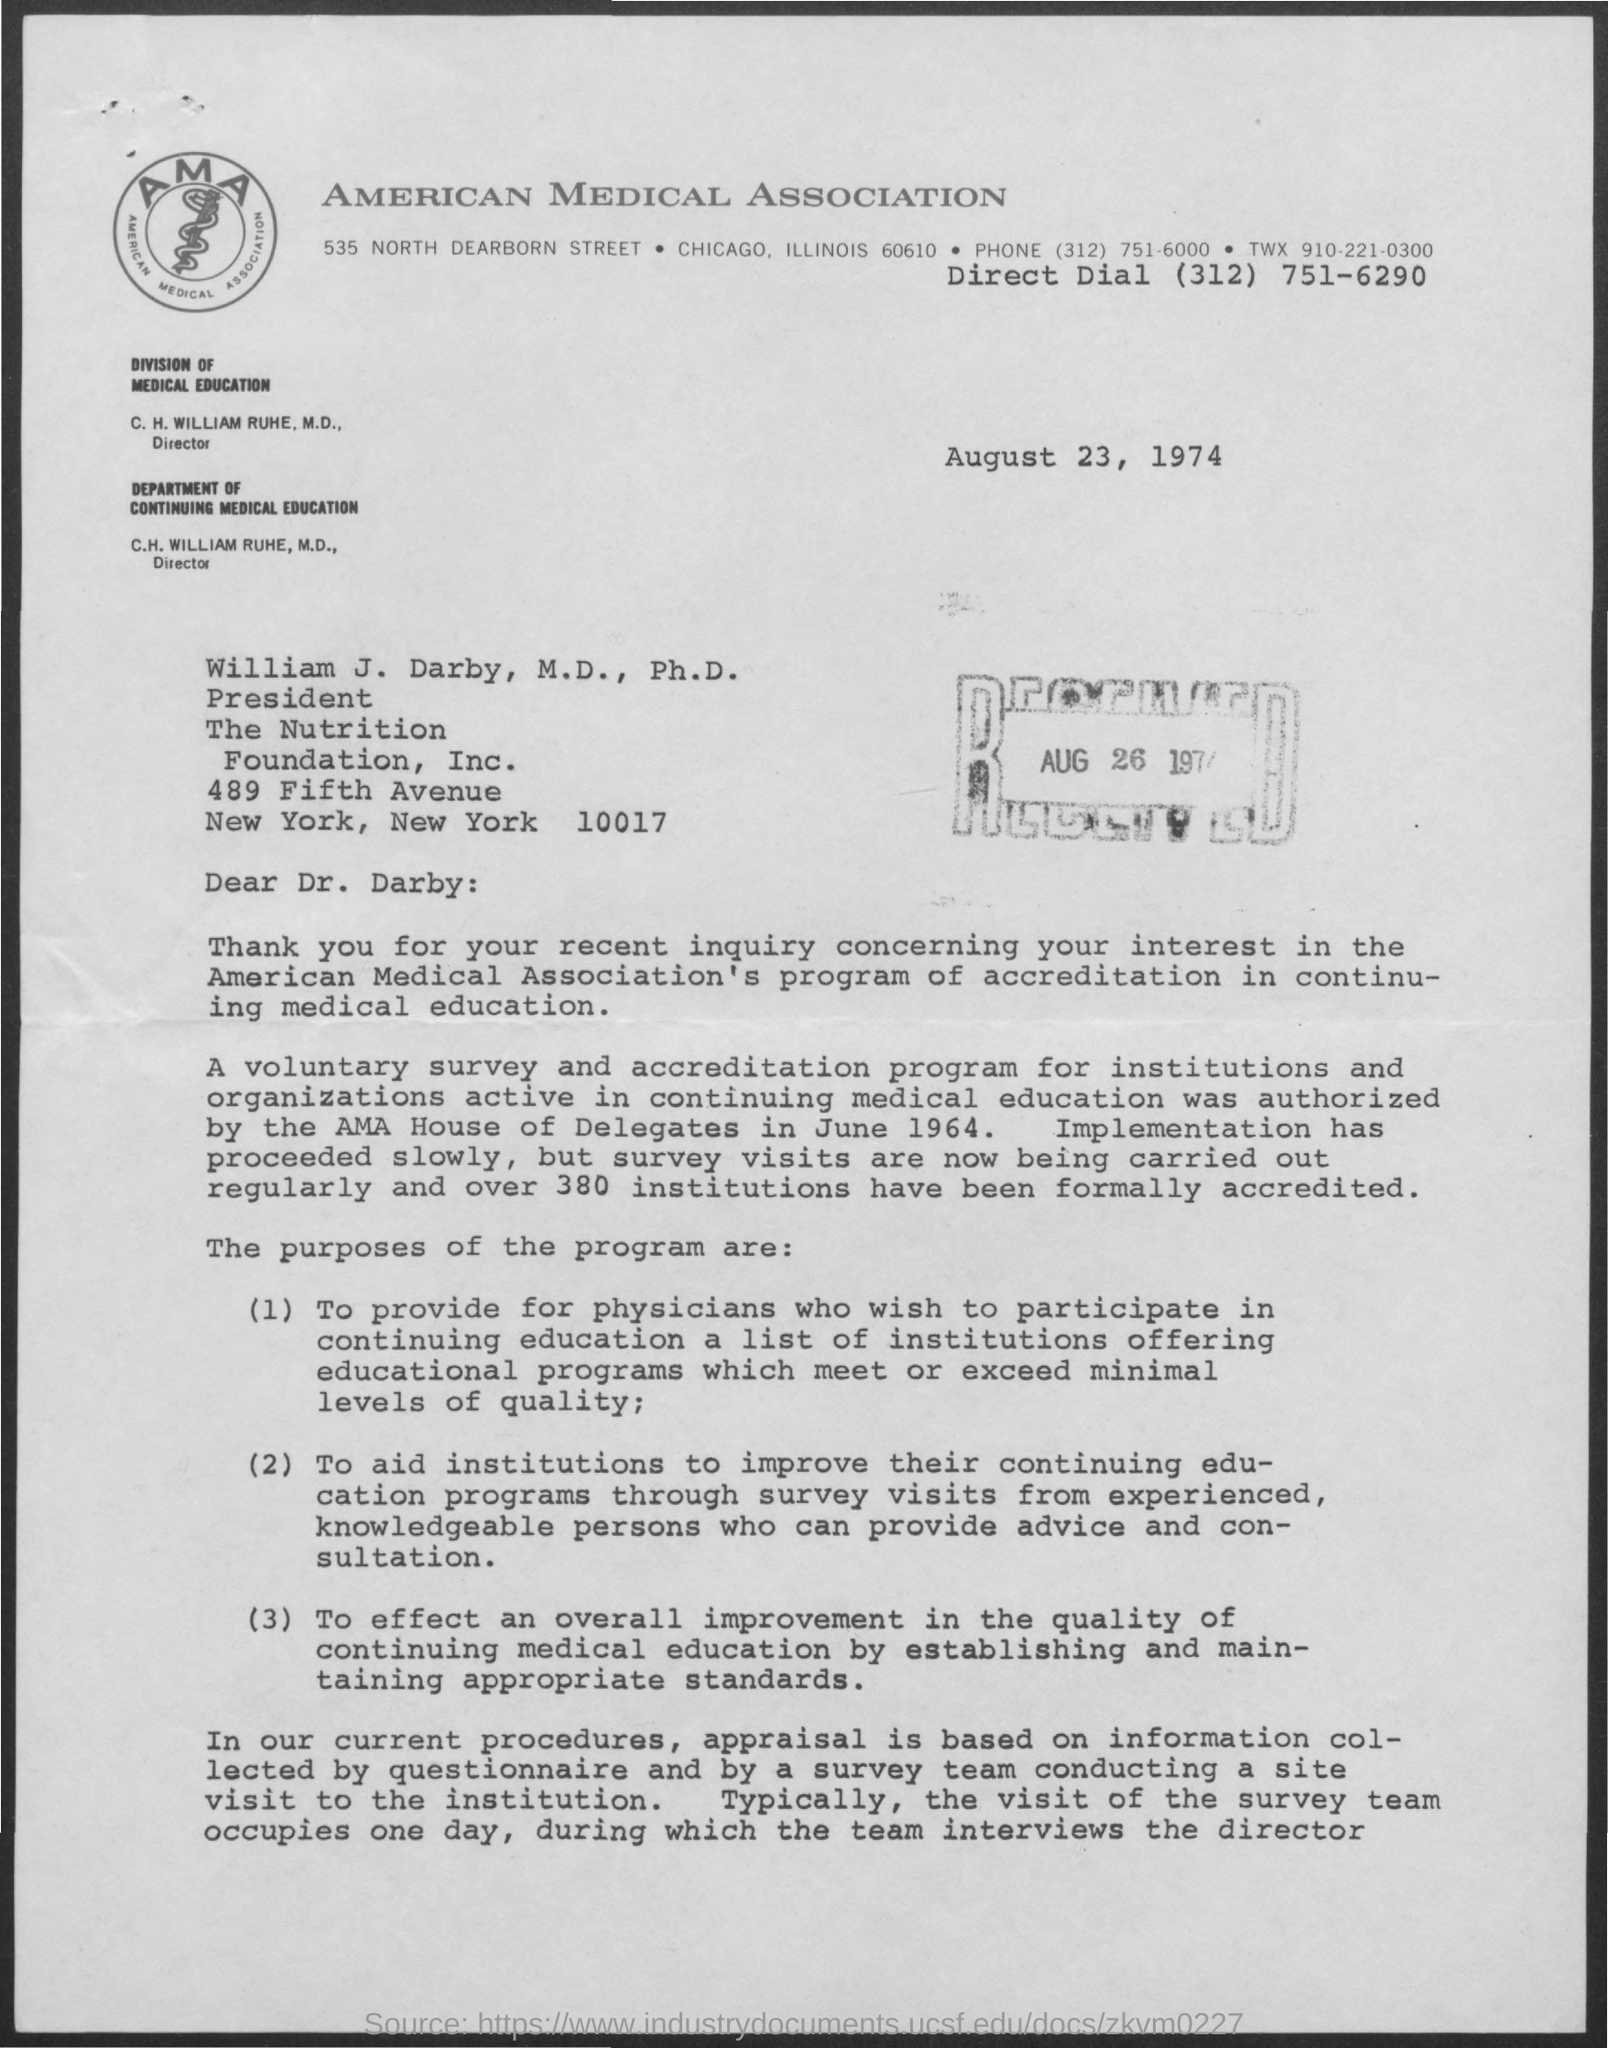When was this program started?
Your answer should be compact. June 1964. Who authorized the Program?
Your answer should be compact. AMA House of Delegates. How many institutes were accredited?
Ensure brevity in your answer.  Over 380. How many days will the survey team take for Survey?
Provide a succinct answer. One day. 